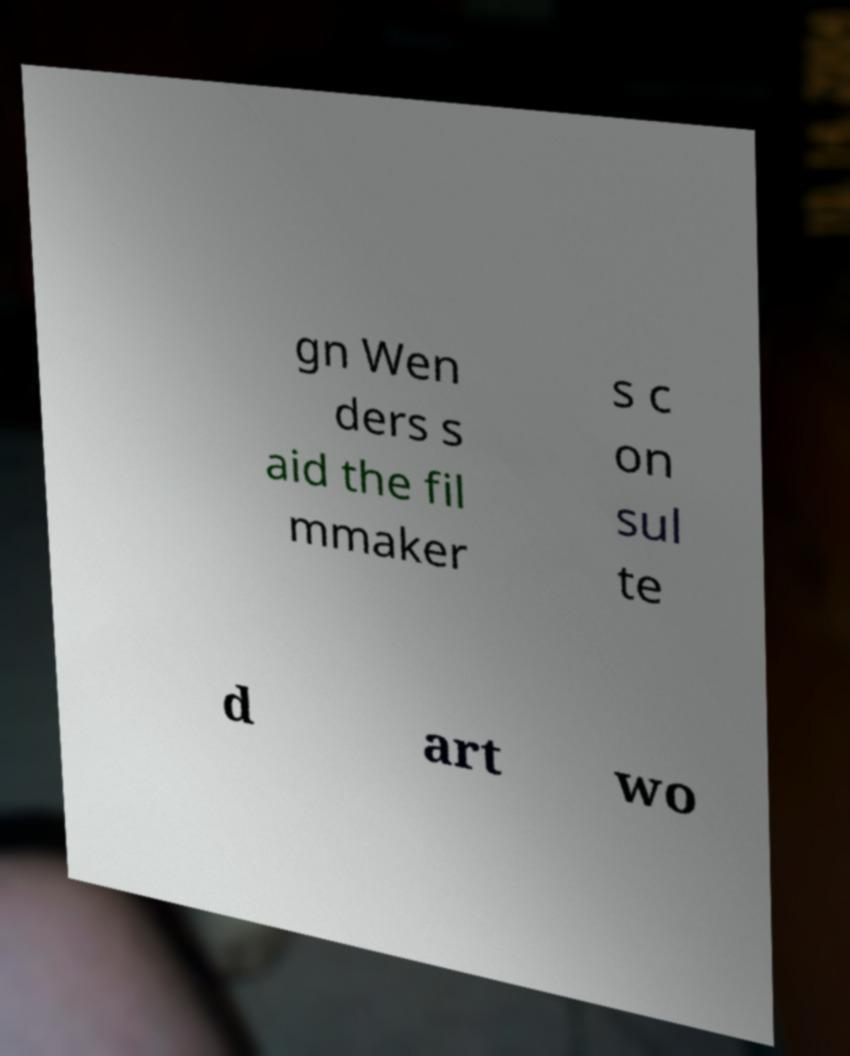Please read and relay the text visible in this image. What does it say? gn Wen ders s aid the fil mmaker s c on sul te d art wo 